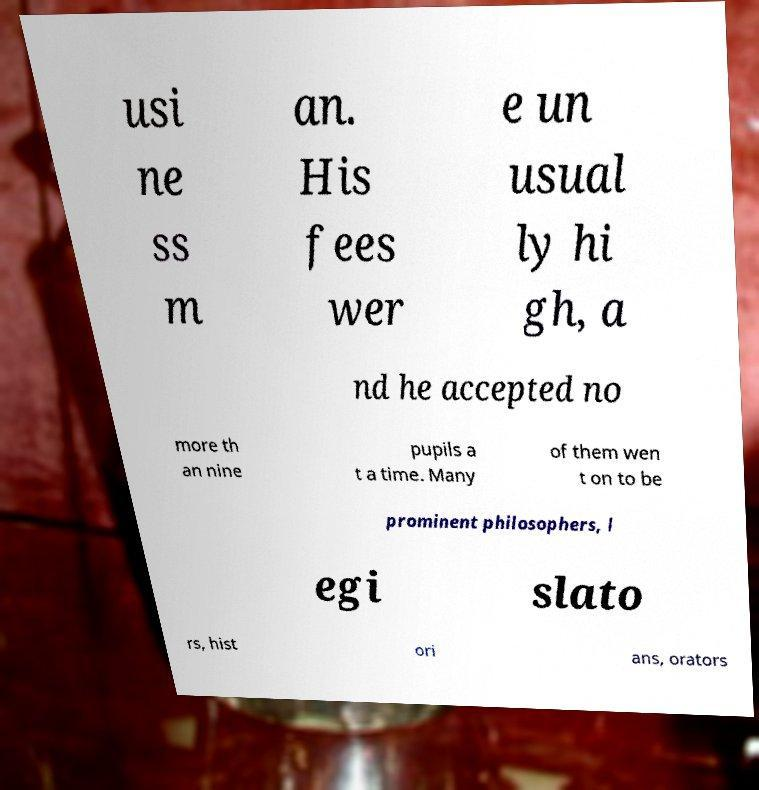Please identify and transcribe the text found in this image. usi ne ss m an. His fees wer e un usual ly hi gh, a nd he accepted no more th an nine pupils a t a time. Many of them wen t on to be prominent philosophers, l egi slato rs, hist ori ans, orators 